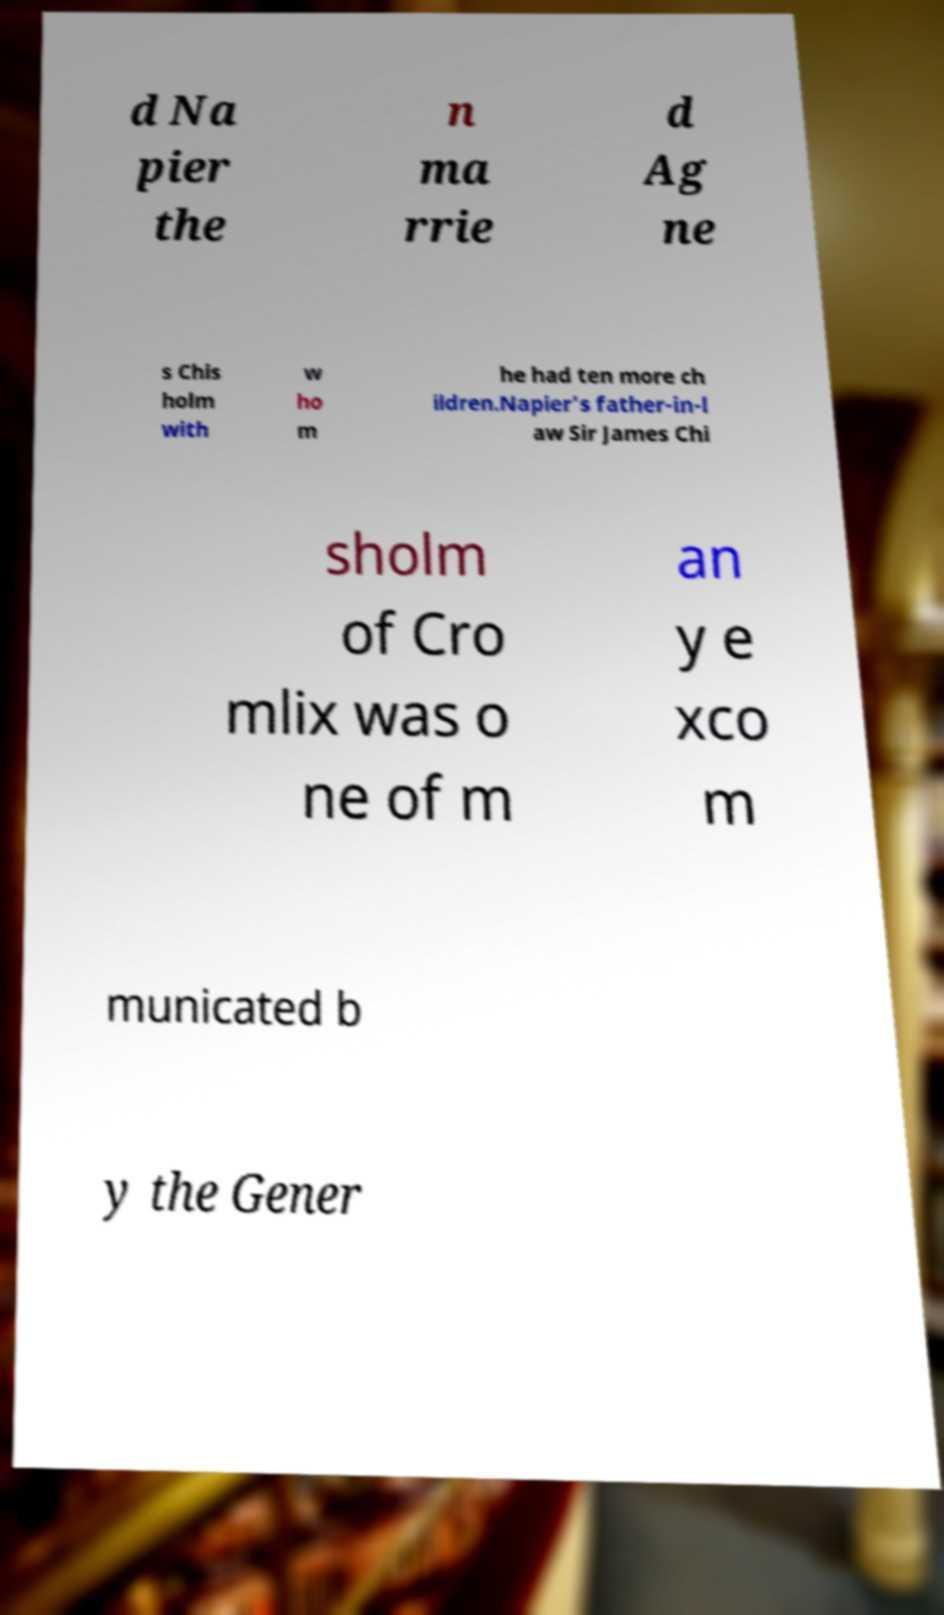Please identify and transcribe the text found in this image. d Na pier the n ma rrie d Ag ne s Chis holm with w ho m he had ten more ch ildren.Napier's father-in-l aw Sir James Chi sholm of Cro mlix was o ne of m an y e xco m municated b y the Gener 